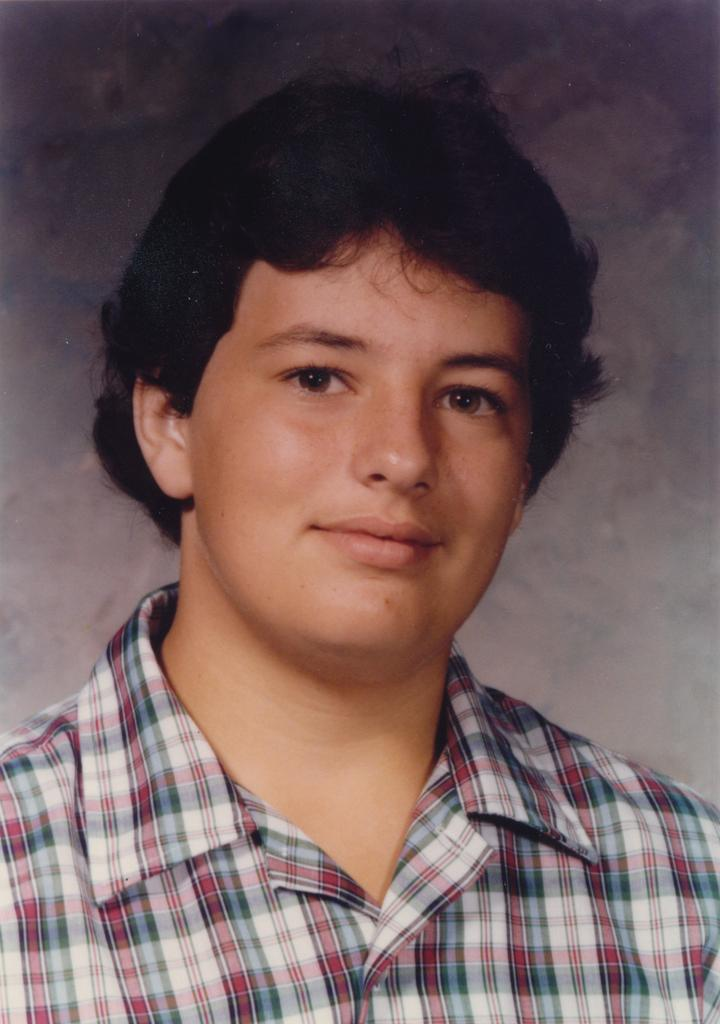What is present in the image? There is a person in the image. Can you describe the person's clothing? The person is wearing a shirt. What type of hose is the person using in the image? There is no hose present in the image. How many hands does the person have in the image? The image only shows the person from the front, so it is impossible to determine the number of hands they have. 